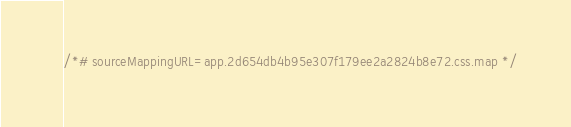<code> <loc_0><loc_0><loc_500><loc_500><_CSS_>/*# sourceMappingURL=app.2d654db4b95e307f179ee2a2824b8e72.css.map */</code> 